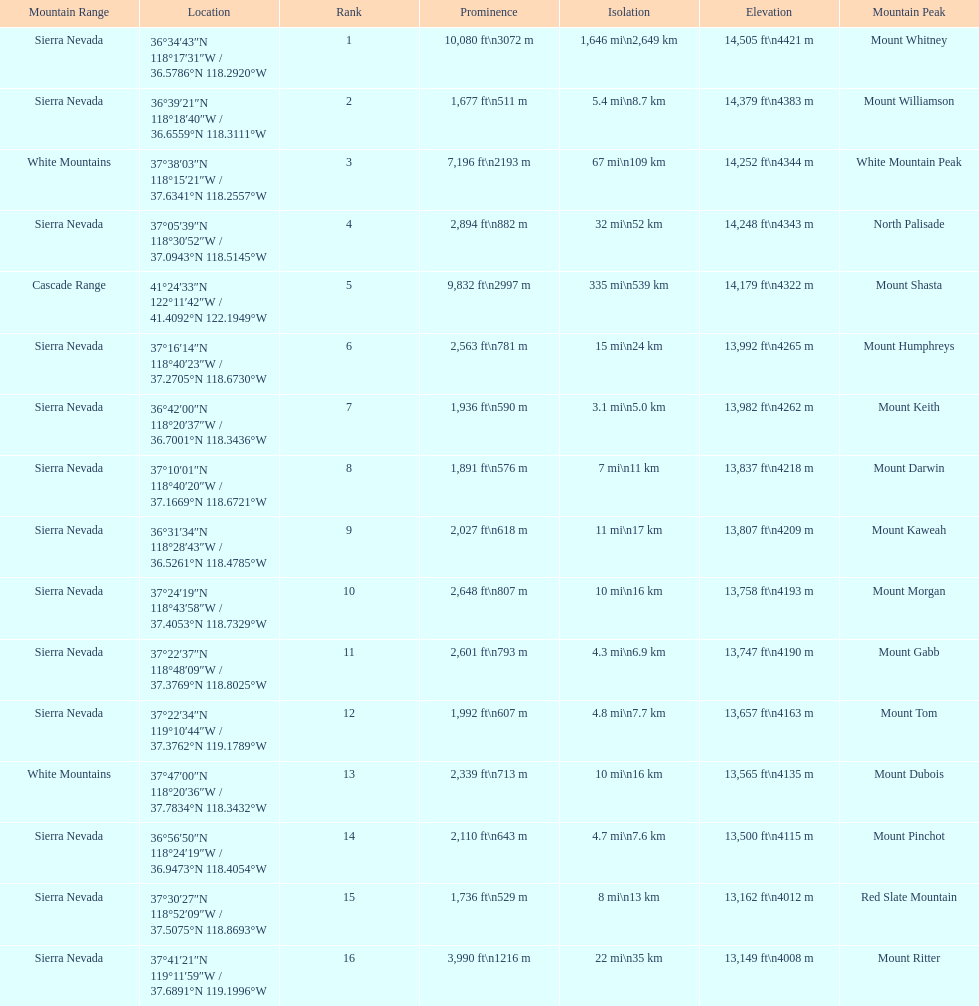Which mountain peak is no higher than 13,149 ft? Mount Ritter. 